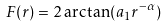Convert formula to latex. <formula><loc_0><loc_0><loc_500><loc_500>F ( r ) = 2 \arctan ( a _ { 1 } r ^ { - \alpha } )</formula> 